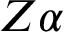<formula> <loc_0><loc_0><loc_500><loc_500>Z \alpha</formula> 